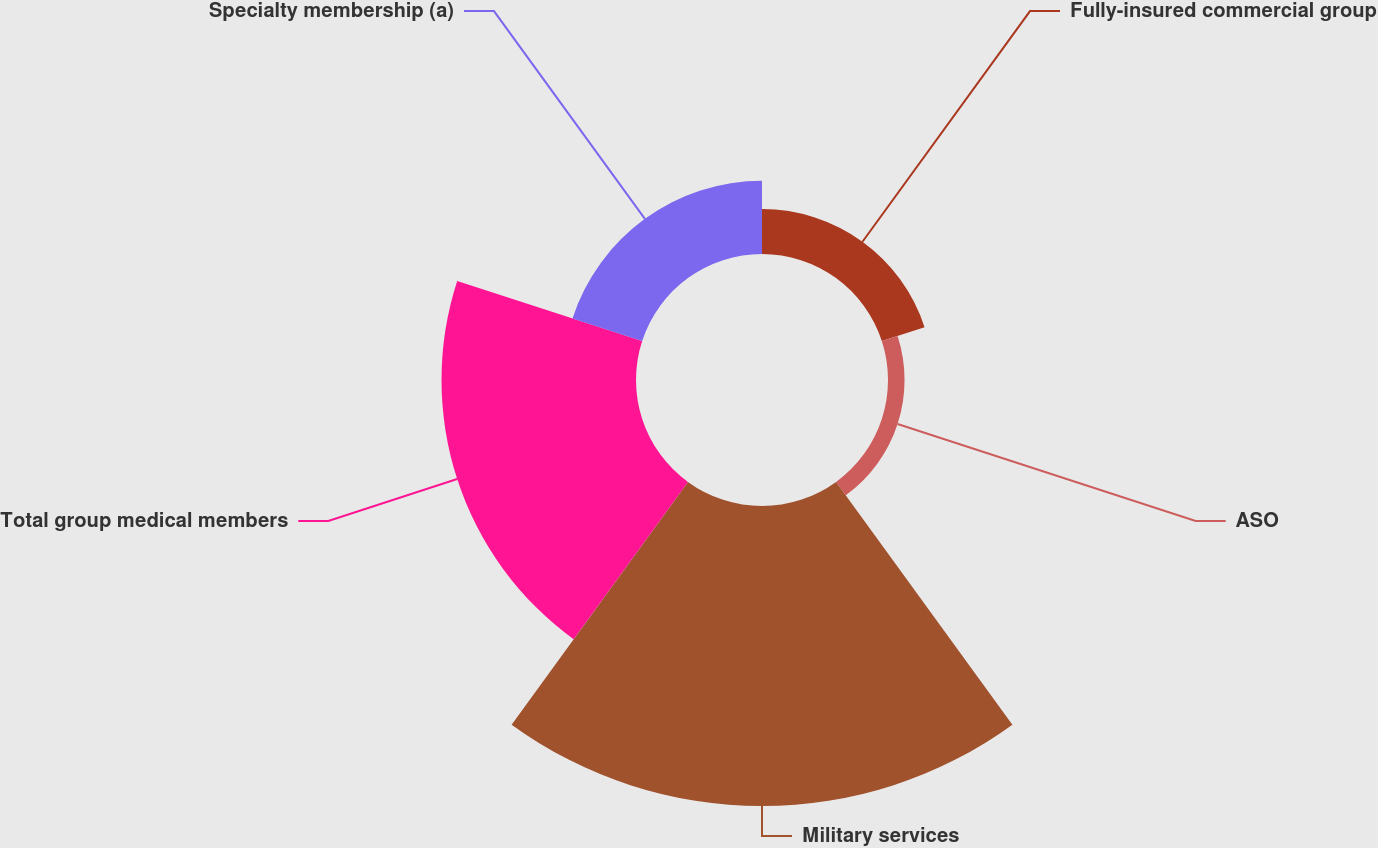<chart> <loc_0><loc_0><loc_500><loc_500><pie_chart><fcel>Fully-insured commercial group<fcel>ASO<fcel>Military services<fcel>Total group medical members<fcel>Specialty membership (a)<nl><fcel>7.14%<fcel>2.63%<fcel>47.68%<fcel>30.91%<fcel>11.64%<nl></chart> 